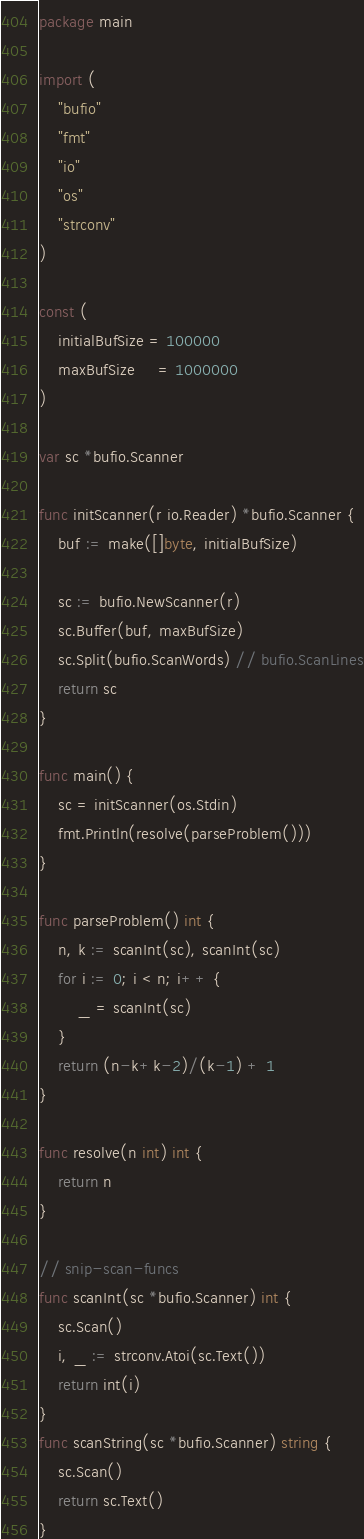<code> <loc_0><loc_0><loc_500><loc_500><_Go_>package main

import (
	"bufio"
	"fmt"
	"io"
	"os"
	"strconv"
)

const (
	initialBufSize = 100000
	maxBufSize     = 1000000
)

var sc *bufio.Scanner

func initScanner(r io.Reader) *bufio.Scanner {
	buf := make([]byte, initialBufSize)

	sc := bufio.NewScanner(r)
	sc.Buffer(buf, maxBufSize)
	sc.Split(bufio.ScanWords) // bufio.ScanLines
	return sc
}

func main() {
	sc = initScanner(os.Stdin)
	fmt.Println(resolve(parseProblem()))
}

func parseProblem() int {
	n, k := scanInt(sc), scanInt(sc)
	for i := 0; i < n; i++ {
		_ = scanInt(sc)
	}
	return (n-k+k-2)/(k-1) + 1
}

func resolve(n int) int {
	return n
}

// snip-scan-funcs
func scanInt(sc *bufio.Scanner) int {
	sc.Scan()
	i, _ := strconv.Atoi(sc.Text())
	return int(i)
}
func scanString(sc *bufio.Scanner) string {
	sc.Scan()
	return sc.Text()
}
</code> 